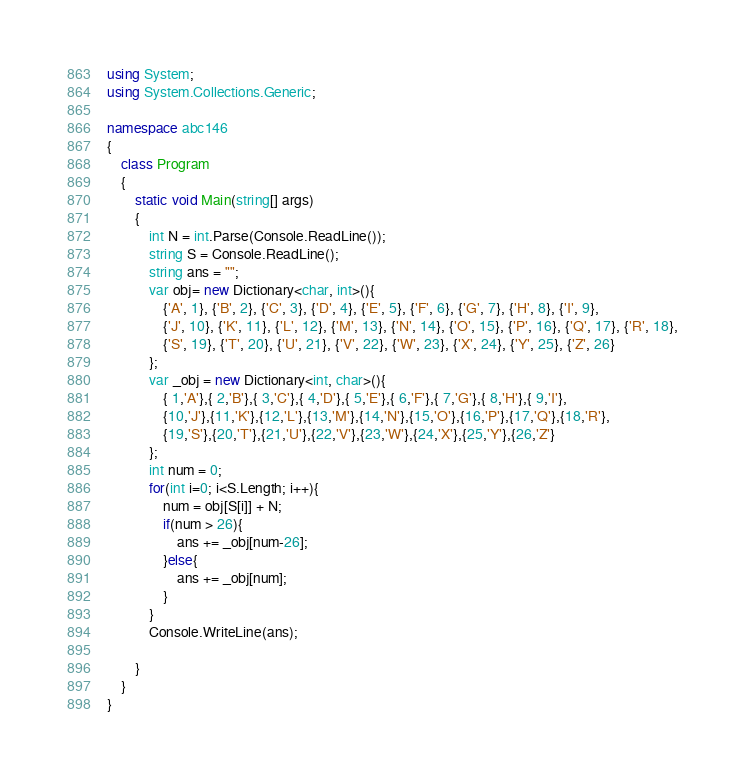<code> <loc_0><loc_0><loc_500><loc_500><_C#_>using System;
using System.Collections.Generic;

namespace abc146
{
    class Program
    {
        static void Main(string[] args)
        {
            int N = int.Parse(Console.ReadLine());
            string S = Console.ReadLine();
            string ans = "";
            var obj= new Dictionary<char, int>(){
                {'A', 1}, {'B', 2}, {'C', 3}, {'D', 4}, {'E', 5}, {'F', 6}, {'G', 7}, {'H', 8}, {'I', 9},
                {'J', 10}, {'K', 11}, {'L', 12}, {'M', 13}, {'N', 14}, {'O', 15}, {'P', 16}, {'Q', 17}, {'R', 18},
                {'S', 19}, {'T', 20}, {'U', 21}, {'V', 22}, {'W', 23}, {'X', 24}, {'Y', 25}, {'Z', 26}
            };
            var _obj = new Dictionary<int, char>(){
                { 1,'A'},{ 2,'B'},{ 3,'C'},{ 4,'D'},{ 5,'E'},{ 6,'F'},{ 7,'G'},{ 8,'H'},{ 9,'I'},
                {10,'J'},{11,'K'},{12,'L'},{13,'M'},{14,'N'},{15,'O'},{16,'P'},{17,'Q'},{18,'R'},
                {19,'S'},{20,'T'},{21,'U'},{22,'V'},{23,'W'},{24,'X'},{25,'Y'},{26,'Z'}
            };
            int num = 0;
            for(int i=0; i<S.Length; i++){
                num = obj[S[i]] + N;
                if(num > 26){
                    ans += _obj[num-26];
                }else{
                    ans += _obj[num];
                }
            }
            Console.WriteLine(ans);

        }
    }
}</code> 